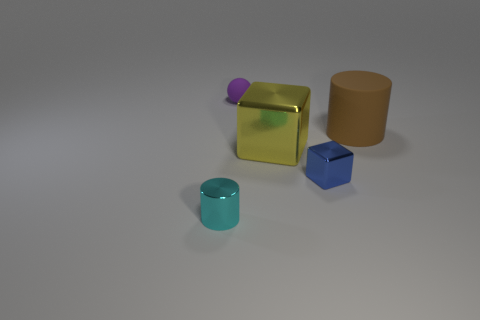Add 3 big spheres. How many objects exist? 8 Subtract 1 cubes. How many cubes are left? 1 Subtract all cylinders. How many objects are left? 3 Subtract all red cylinders. Subtract all brown cylinders. How many objects are left? 4 Add 5 blue shiny objects. How many blue shiny objects are left? 6 Add 4 purple balls. How many purple balls exist? 5 Subtract 1 yellow blocks. How many objects are left? 4 Subtract all purple cylinders. Subtract all cyan blocks. How many cylinders are left? 2 Subtract all green cylinders. How many blue cubes are left? 1 